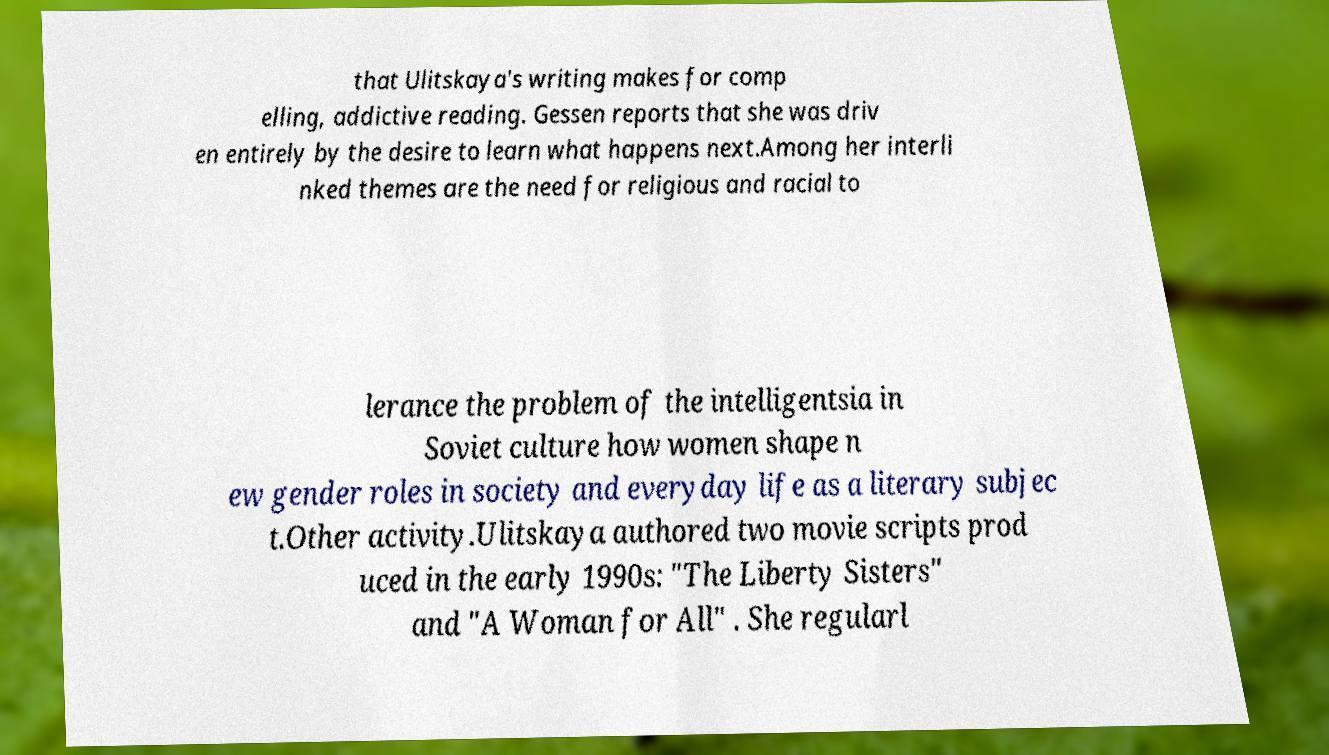Could you extract and type out the text from this image? that Ulitskaya's writing makes for comp elling, addictive reading. Gessen reports that she was driv en entirely by the desire to learn what happens next.Among her interli nked themes are the need for religious and racial to lerance the problem of the intelligentsia in Soviet culture how women shape n ew gender roles in society and everyday life as a literary subjec t.Other activity.Ulitskaya authored two movie scripts prod uced in the early 1990s: "The Liberty Sisters" and "A Woman for All" . She regularl 